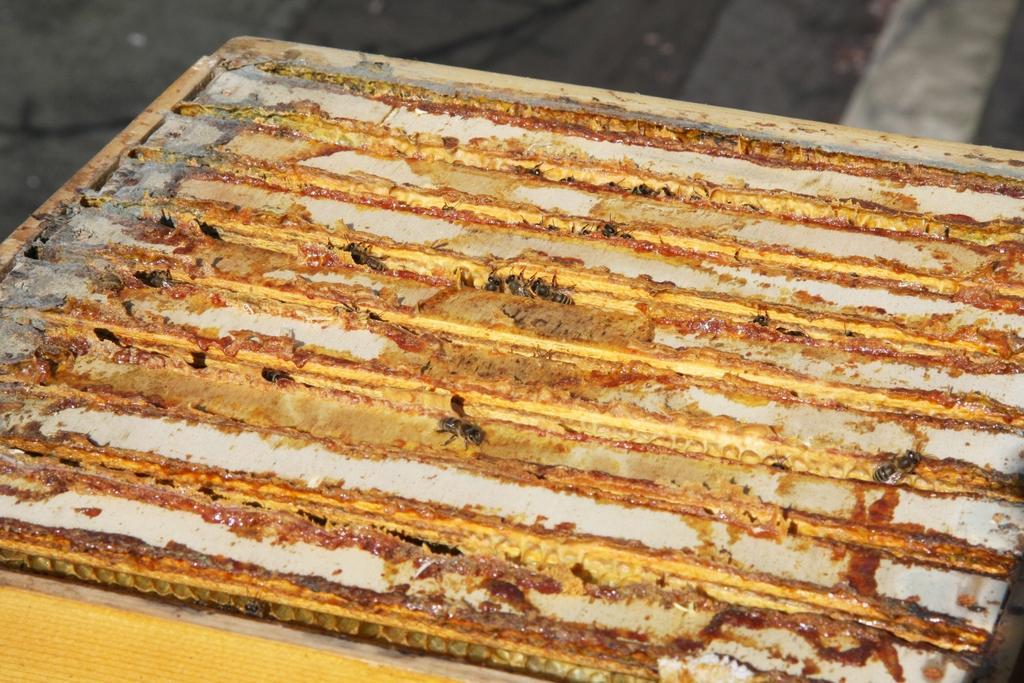In one or two sentences, can you explain what this image depicts? In this image, I can see few bees on a board. At the top of the image I can see the floor. 